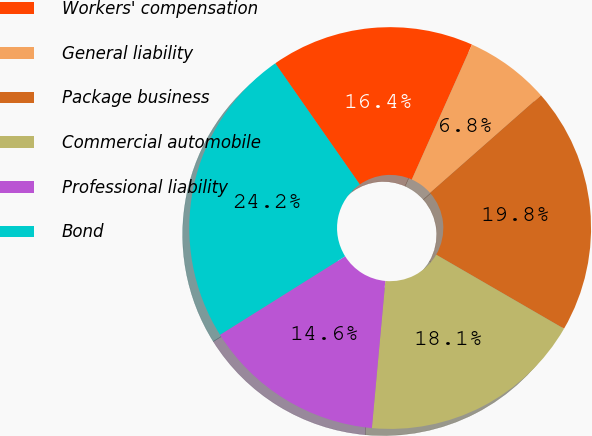Convert chart to OTSL. <chart><loc_0><loc_0><loc_500><loc_500><pie_chart><fcel>Workers' compensation<fcel>General liability<fcel>Package business<fcel>Commercial automobile<fcel>Professional liability<fcel>Bond<nl><fcel>16.37%<fcel>6.84%<fcel>19.84%<fcel>18.1%<fcel>14.63%<fcel>24.22%<nl></chart> 